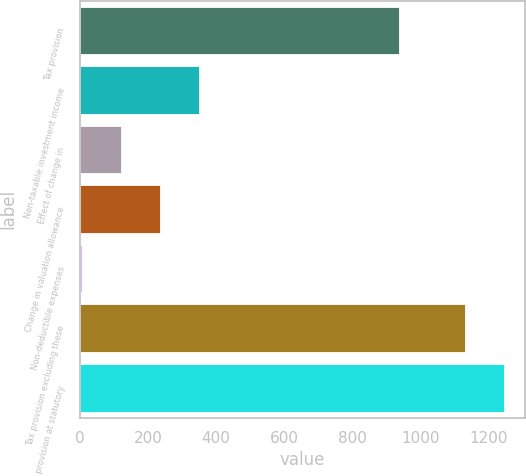Convert chart to OTSL. <chart><loc_0><loc_0><loc_500><loc_500><bar_chart><fcel>Tax provision<fcel>Non-taxable investment income<fcel>Effect of change in<fcel>Change in valuation allowance<fcel>Non-deductible expenses<fcel>Tax provision excluding these<fcel>Tax provision at statutory<nl><fcel>938<fcel>349.2<fcel>120.4<fcel>234.8<fcel>6<fcel>1129<fcel>1243.4<nl></chart> 